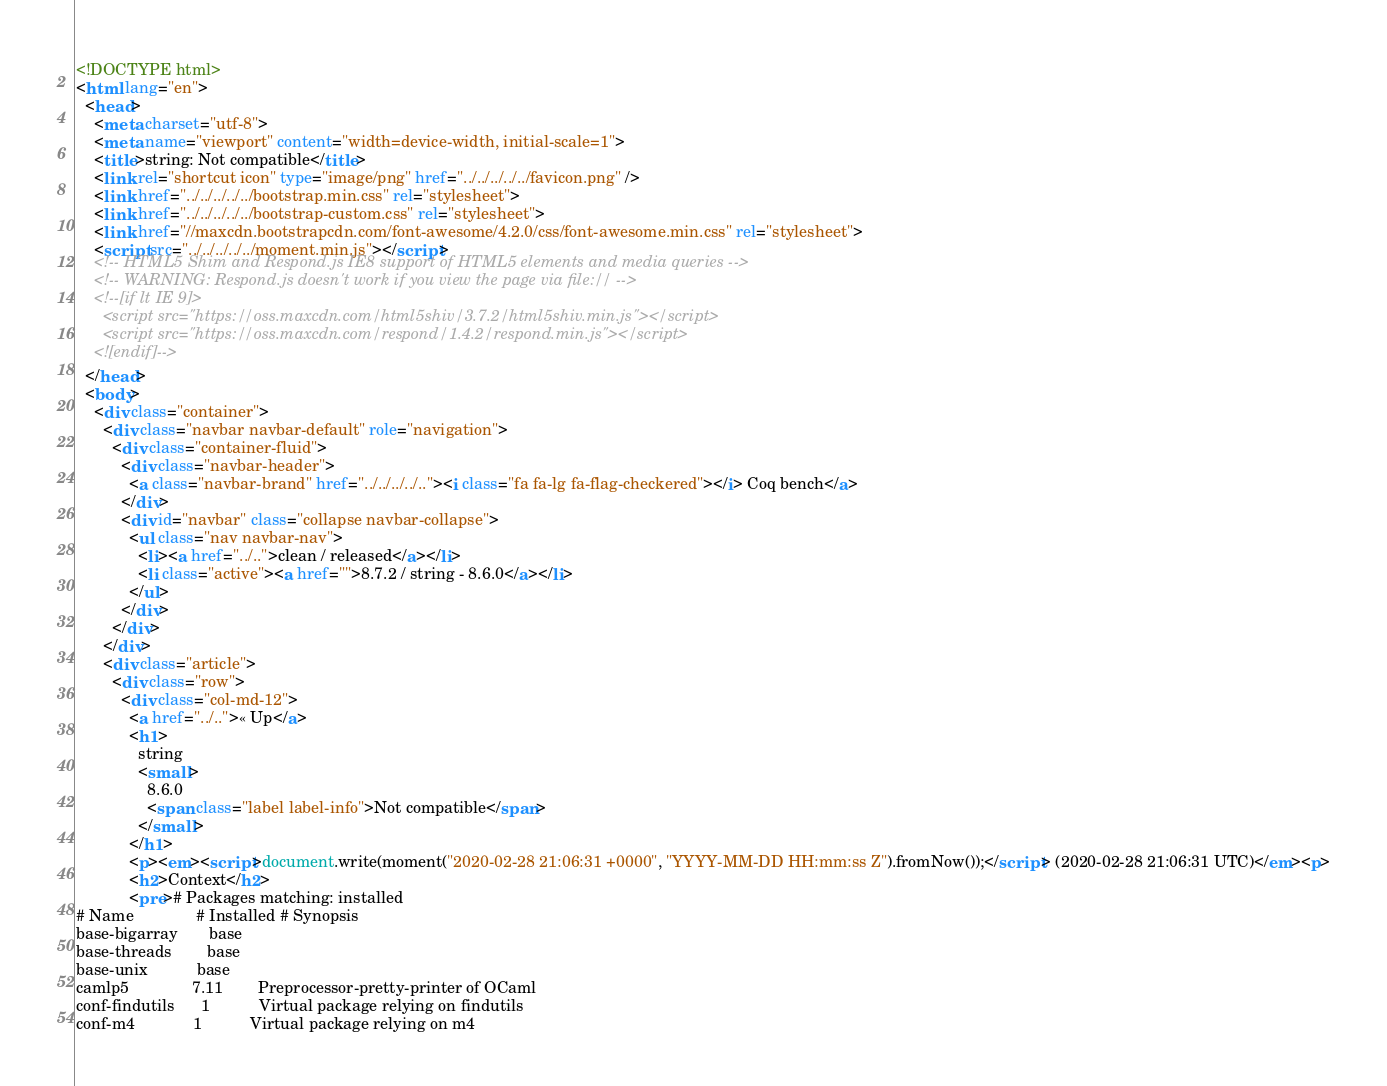<code> <loc_0><loc_0><loc_500><loc_500><_HTML_><!DOCTYPE html>
<html lang="en">
  <head>
    <meta charset="utf-8">
    <meta name="viewport" content="width=device-width, initial-scale=1">
    <title>string: Not compatible</title>
    <link rel="shortcut icon" type="image/png" href="../../../../../favicon.png" />
    <link href="../../../../../bootstrap.min.css" rel="stylesheet">
    <link href="../../../../../bootstrap-custom.css" rel="stylesheet">
    <link href="//maxcdn.bootstrapcdn.com/font-awesome/4.2.0/css/font-awesome.min.css" rel="stylesheet">
    <script src="../../../../../moment.min.js"></script>
    <!-- HTML5 Shim and Respond.js IE8 support of HTML5 elements and media queries -->
    <!-- WARNING: Respond.js doesn't work if you view the page via file:// -->
    <!--[if lt IE 9]>
      <script src="https://oss.maxcdn.com/html5shiv/3.7.2/html5shiv.min.js"></script>
      <script src="https://oss.maxcdn.com/respond/1.4.2/respond.min.js"></script>
    <![endif]-->
  </head>
  <body>
    <div class="container">
      <div class="navbar navbar-default" role="navigation">
        <div class="container-fluid">
          <div class="navbar-header">
            <a class="navbar-brand" href="../../../../.."><i class="fa fa-lg fa-flag-checkered"></i> Coq bench</a>
          </div>
          <div id="navbar" class="collapse navbar-collapse">
            <ul class="nav navbar-nav">
              <li><a href="../..">clean / released</a></li>
              <li class="active"><a href="">8.7.2 / string - 8.6.0</a></li>
            </ul>
          </div>
        </div>
      </div>
      <div class="article">
        <div class="row">
          <div class="col-md-12">
            <a href="../..">« Up</a>
            <h1>
              string
              <small>
                8.6.0
                <span class="label label-info">Not compatible</span>
              </small>
            </h1>
            <p><em><script>document.write(moment("2020-02-28 21:06:31 +0000", "YYYY-MM-DD HH:mm:ss Z").fromNow());</script> (2020-02-28 21:06:31 UTC)</em><p>
            <h2>Context</h2>
            <pre># Packages matching: installed
# Name              # Installed # Synopsis
base-bigarray       base
base-threads        base
base-unix           base
camlp5              7.11        Preprocessor-pretty-printer of OCaml
conf-findutils      1           Virtual package relying on findutils
conf-m4             1           Virtual package relying on m4</code> 